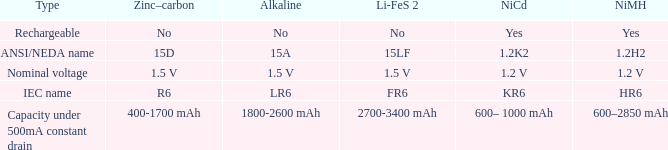What is NiCd, when Type is "Capacity under 500mA constant Drain"? 600– 1000 mAh. 